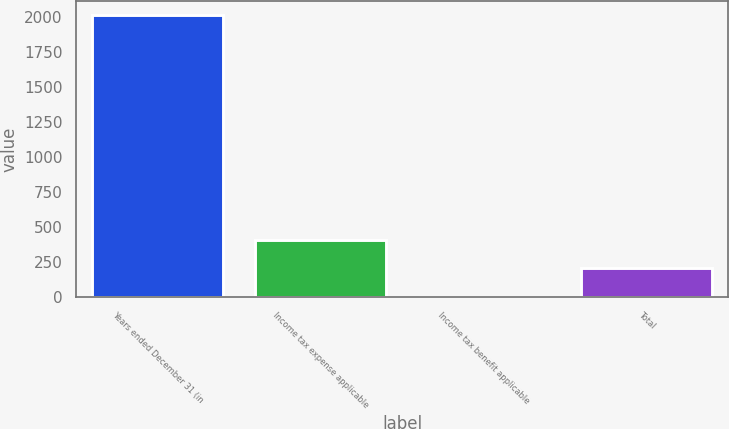Convert chart to OTSL. <chart><loc_0><loc_0><loc_500><loc_500><bar_chart><fcel>Years ended December 31 (in<fcel>Income tax expense applicable<fcel>Income tax benefit applicable<fcel>Total<nl><fcel>2015<fcel>407.24<fcel>5.3<fcel>206.27<nl></chart> 